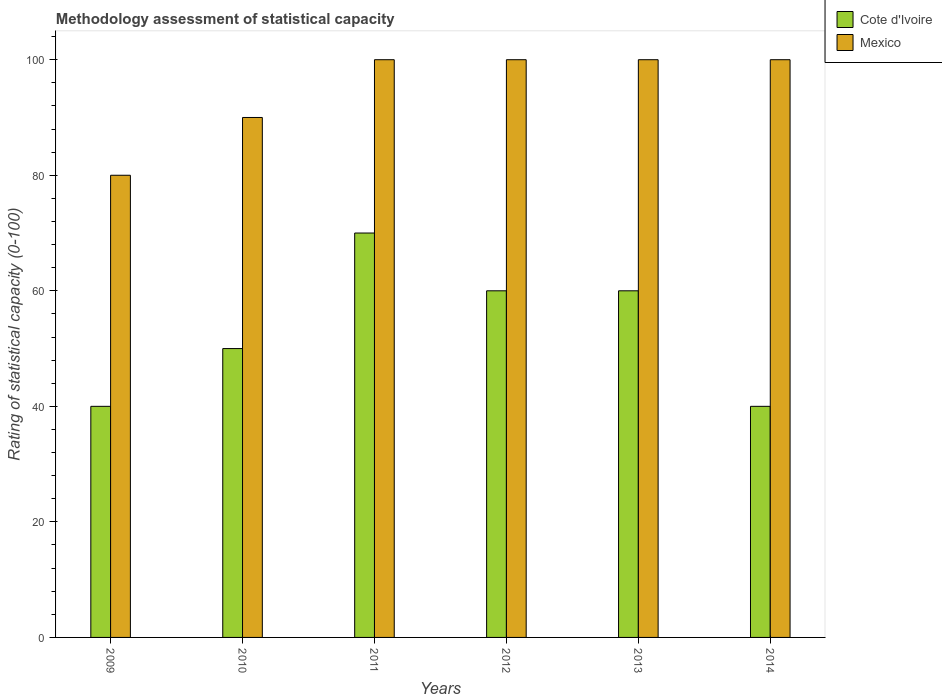What is the label of the 6th group of bars from the left?
Your response must be concise. 2014. What is the rating of statistical capacity in Mexico in 2013?
Make the answer very short. 100. Across all years, what is the maximum rating of statistical capacity in Mexico?
Your answer should be very brief. 100. Across all years, what is the minimum rating of statistical capacity in Cote d'Ivoire?
Your answer should be compact. 40. In which year was the rating of statistical capacity in Mexico maximum?
Provide a succinct answer. 2011. What is the total rating of statistical capacity in Mexico in the graph?
Ensure brevity in your answer.  570. What is the difference between the rating of statistical capacity in Mexico in 2011 and that in 2012?
Your answer should be very brief. 0. What is the difference between the rating of statistical capacity in Cote d'Ivoire in 2011 and the rating of statistical capacity in Mexico in 2009?
Offer a very short reply. -10. What is the average rating of statistical capacity in Mexico per year?
Offer a very short reply. 95. In the year 2011, what is the difference between the rating of statistical capacity in Cote d'Ivoire and rating of statistical capacity in Mexico?
Keep it short and to the point. -30. What is the ratio of the rating of statistical capacity in Mexico in 2009 to that in 2013?
Keep it short and to the point. 0.8. Is the rating of statistical capacity in Cote d'Ivoire in 2011 less than that in 2014?
Your answer should be compact. No. Is the difference between the rating of statistical capacity in Cote d'Ivoire in 2011 and 2013 greater than the difference between the rating of statistical capacity in Mexico in 2011 and 2013?
Make the answer very short. Yes. What is the difference between the highest and the second highest rating of statistical capacity in Mexico?
Your answer should be compact. 0. What is the difference between the highest and the lowest rating of statistical capacity in Cote d'Ivoire?
Provide a succinct answer. 30. In how many years, is the rating of statistical capacity in Cote d'Ivoire greater than the average rating of statistical capacity in Cote d'Ivoire taken over all years?
Offer a very short reply. 3. What does the 2nd bar from the right in 2011 represents?
Make the answer very short. Cote d'Ivoire. How many bars are there?
Provide a short and direct response. 12. Are all the bars in the graph horizontal?
Ensure brevity in your answer.  No. How many years are there in the graph?
Your answer should be compact. 6. Does the graph contain grids?
Provide a short and direct response. No. How many legend labels are there?
Offer a very short reply. 2. What is the title of the graph?
Make the answer very short. Methodology assessment of statistical capacity. What is the label or title of the Y-axis?
Your response must be concise. Rating of statistical capacity (0-100). What is the Rating of statistical capacity (0-100) in Cote d'Ivoire in 2009?
Offer a very short reply. 40. What is the Rating of statistical capacity (0-100) in Mexico in 2009?
Make the answer very short. 80. What is the Rating of statistical capacity (0-100) of Mexico in 2010?
Your response must be concise. 90. What is the Rating of statistical capacity (0-100) of Cote d'Ivoire in 2011?
Your answer should be very brief. 70. What is the Rating of statistical capacity (0-100) of Cote d'Ivoire in 2013?
Your answer should be compact. 60. Across all years, what is the maximum Rating of statistical capacity (0-100) in Mexico?
Ensure brevity in your answer.  100. What is the total Rating of statistical capacity (0-100) in Cote d'Ivoire in the graph?
Keep it short and to the point. 320. What is the total Rating of statistical capacity (0-100) in Mexico in the graph?
Ensure brevity in your answer.  570. What is the difference between the Rating of statistical capacity (0-100) of Mexico in 2009 and that in 2011?
Your answer should be compact. -20. What is the difference between the Rating of statistical capacity (0-100) in Cote d'Ivoire in 2009 and that in 2012?
Provide a succinct answer. -20. What is the difference between the Rating of statistical capacity (0-100) in Mexico in 2009 and that in 2014?
Your answer should be very brief. -20. What is the difference between the Rating of statistical capacity (0-100) of Mexico in 2010 and that in 2011?
Offer a very short reply. -10. What is the difference between the Rating of statistical capacity (0-100) in Mexico in 2010 and that in 2012?
Make the answer very short. -10. What is the difference between the Rating of statistical capacity (0-100) in Cote d'Ivoire in 2010 and that in 2013?
Provide a short and direct response. -10. What is the difference between the Rating of statistical capacity (0-100) of Mexico in 2010 and that in 2013?
Make the answer very short. -10. What is the difference between the Rating of statistical capacity (0-100) of Mexico in 2010 and that in 2014?
Offer a terse response. -10. What is the difference between the Rating of statistical capacity (0-100) in Cote d'Ivoire in 2011 and that in 2012?
Ensure brevity in your answer.  10. What is the difference between the Rating of statistical capacity (0-100) of Mexico in 2011 and that in 2012?
Your answer should be very brief. 0. What is the difference between the Rating of statistical capacity (0-100) of Cote d'Ivoire in 2011 and that in 2014?
Provide a short and direct response. 30. What is the difference between the Rating of statistical capacity (0-100) of Mexico in 2012 and that in 2013?
Provide a short and direct response. 0. What is the difference between the Rating of statistical capacity (0-100) of Cote d'Ivoire in 2009 and the Rating of statistical capacity (0-100) of Mexico in 2011?
Provide a short and direct response. -60. What is the difference between the Rating of statistical capacity (0-100) of Cote d'Ivoire in 2009 and the Rating of statistical capacity (0-100) of Mexico in 2012?
Provide a short and direct response. -60. What is the difference between the Rating of statistical capacity (0-100) of Cote d'Ivoire in 2009 and the Rating of statistical capacity (0-100) of Mexico in 2013?
Offer a very short reply. -60. What is the difference between the Rating of statistical capacity (0-100) in Cote d'Ivoire in 2009 and the Rating of statistical capacity (0-100) in Mexico in 2014?
Make the answer very short. -60. What is the difference between the Rating of statistical capacity (0-100) in Cote d'Ivoire in 2010 and the Rating of statistical capacity (0-100) in Mexico in 2013?
Your answer should be compact. -50. What is the difference between the Rating of statistical capacity (0-100) of Cote d'Ivoire in 2010 and the Rating of statistical capacity (0-100) of Mexico in 2014?
Provide a succinct answer. -50. What is the difference between the Rating of statistical capacity (0-100) of Cote d'Ivoire in 2013 and the Rating of statistical capacity (0-100) of Mexico in 2014?
Your answer should be compact. -40. What is the average Rating of statistical capacity (0-100) of Cote d'Ivoire per year?
Your response must be concise. 53.33. What is the average Rating of statistical capacity (0-100) of Mexico per year?
Your answer should be very brief. 95. In the year 2012, what is the difference between the Rating of statistical capacity (0-100) in Cote d'Ivoire and Rating of statistical capacity (0-100) in Mexico?
Give a very brief answer. -40. In the year 2013, what is the difference between the Rating of statistical capacity (0-100) in Cote d'Ivoire and Rating of statistical capacity (0-100) in Mexico?
Your response must be concise. -40. In the year 2014, what is the difference between the Rating of statistical capacity (0-100) of Cote d'Ivoire and Rating of statistical capacity (0-100) of Mexico?
Make the answer very short. -60. What is the ratio of the Rating of statistical capacity (0-100) in Cote d'Ivoire in 2009 to that in 2010?
Offer a terse response. 0.8. What is the ratio of the Rating of statistical capacity (0-100) in Mexico in 2009 to that in 2010?
Ensure brevity in your answer.  0.89. What is the ratio of the Rating of statistical capacity (0-100) of Mexico in 2009 to that in 2011?
Provide a succinct answer. 0.8. What is the ratio of the Rating of statistical capacity (0-100) in Mexico in 2009 to that in 2012?
Your answer should be very brief. 0.8. What is the ratio of the Rating of statistical capacity (0-100) in Cote d'Ivoire in 2009 to that in 2014?
Your answer should be very brief. 1. What is the ratio of the Rating of statistical capacity (0-100) of Mexico in 2009 to that in 2014?
Your answer should be compact. 0.8. What is the ratio of the Rating of statistical capacity (0-100) in Cote d'Ivoire in 2010 to that in 2011?
Provide a succinct answer. 0.71. What is the ratio of the Rating of statistical capacity (0-100) in Mexico in 2010 to that in 2012?
Make the answer very short. 0.9. What is the ratio of the Rating of statistical capacity (0-100) of Mexico in 2010 to that in 2014?
Your answer should be compact. 0.9. What is the ratio of the Rating of statistical capacity (0-100) in Cote d'Ivoire in 2011 to that in 2014?
Provide a succinct answer. 1.75. What is the ratio of the Rating of statistical capacity (0-100) in Mexico in 2011 to that in 2014?
Offer a terse response. 1. What is the ratio of the Rating of statistical capacity (0-100) of Cote d'Ivoire in 2013 to that in 2014?
Provide a short and direct response. 1.5. What is the ratio of the Rating of statistical capacity (0-100) of Mexico in 2013 to that in 2014?
Your answer should be very brief. 1. What is the difference between the highest and the second highest Rating of statistical capacity (0-100) of Mexico?
Ensure brevity in your answer.  0. What is the difference between the highest and the lowest Rating of statistical capacity (0-100) in Cote d'Ivoire?
Ensure brevity in your answer.  30. 